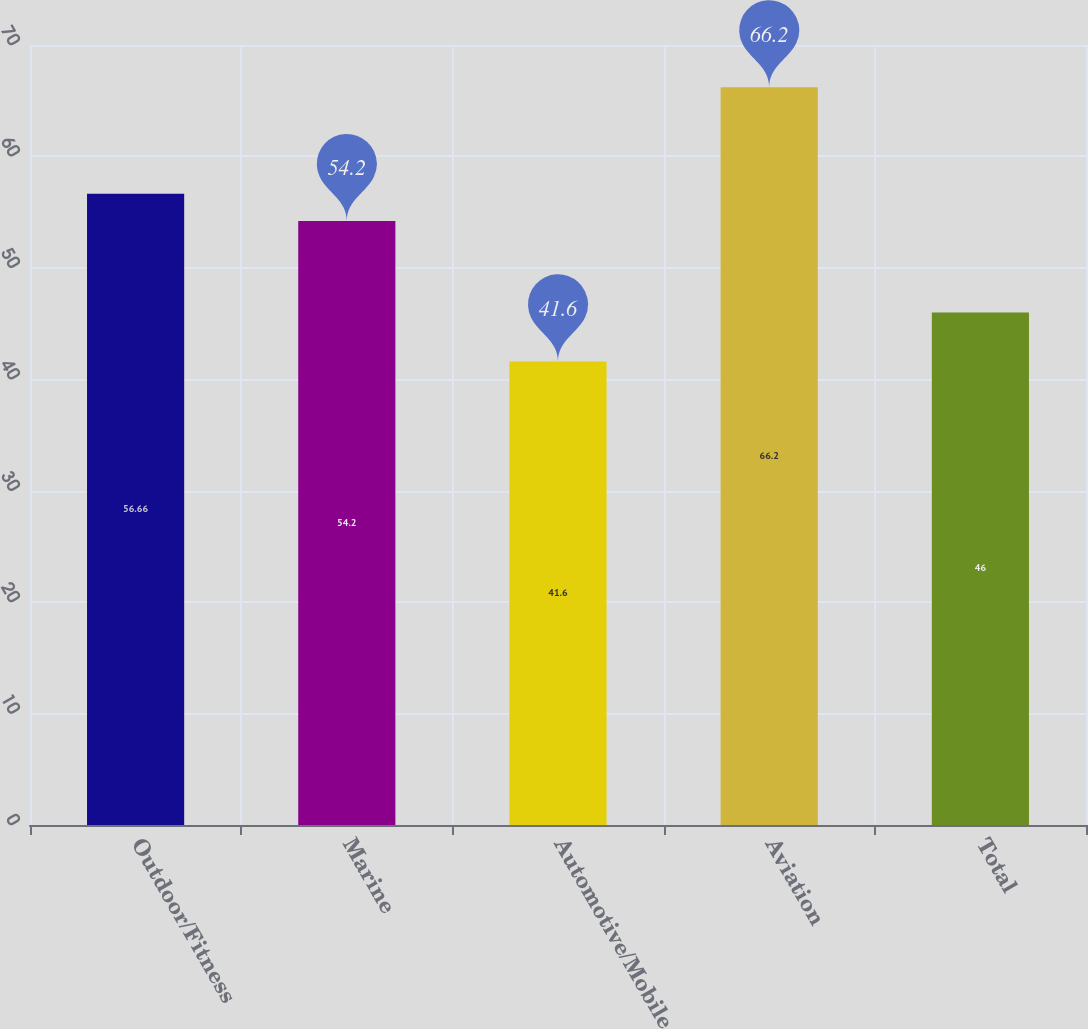Convert chart to OTSL. <chart><loc_0><loc_0><loc_500><loc_500><bar_chart><fcel>Outdoor/Fitness<fcel>Marine<fcel>Automotive/Mobile<fcel>Aviation<fcel>Total<nl><fcel>56.66<fcel>54.2<fcel>41.6<fcel>66.2<fcel>46<nl></chart> 